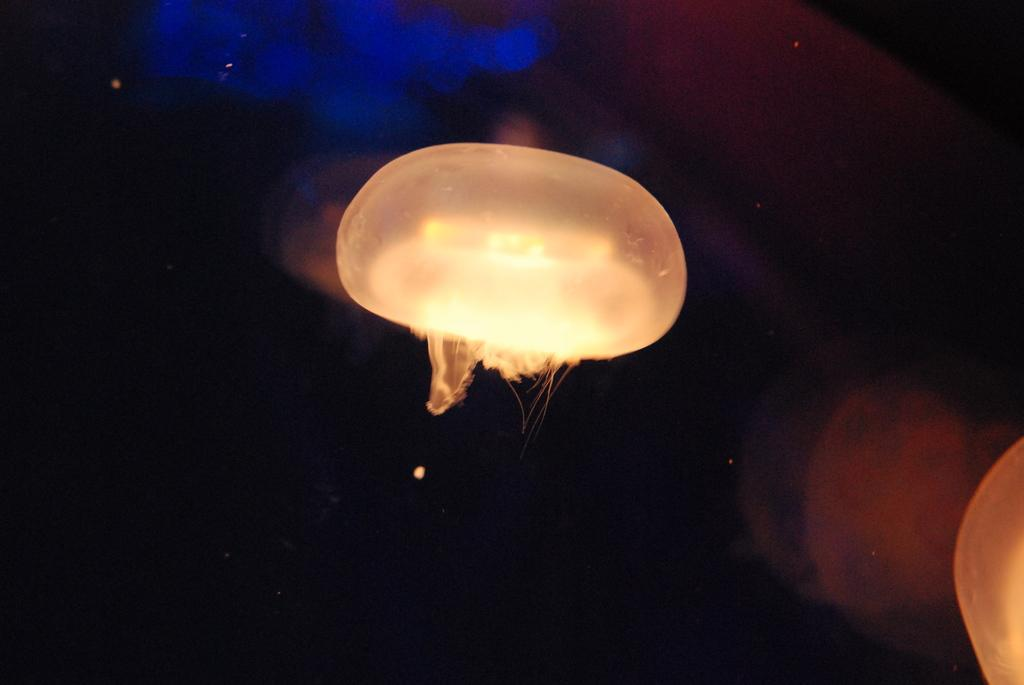What can be seen in the image that provides illumination? There are lights in the image. What is the color or tone of the background in the image? The background of the image is dark. How many babies are being helped to wash in the image? There are no babies or washing activities present in the image; it only features lights and a dark background. 